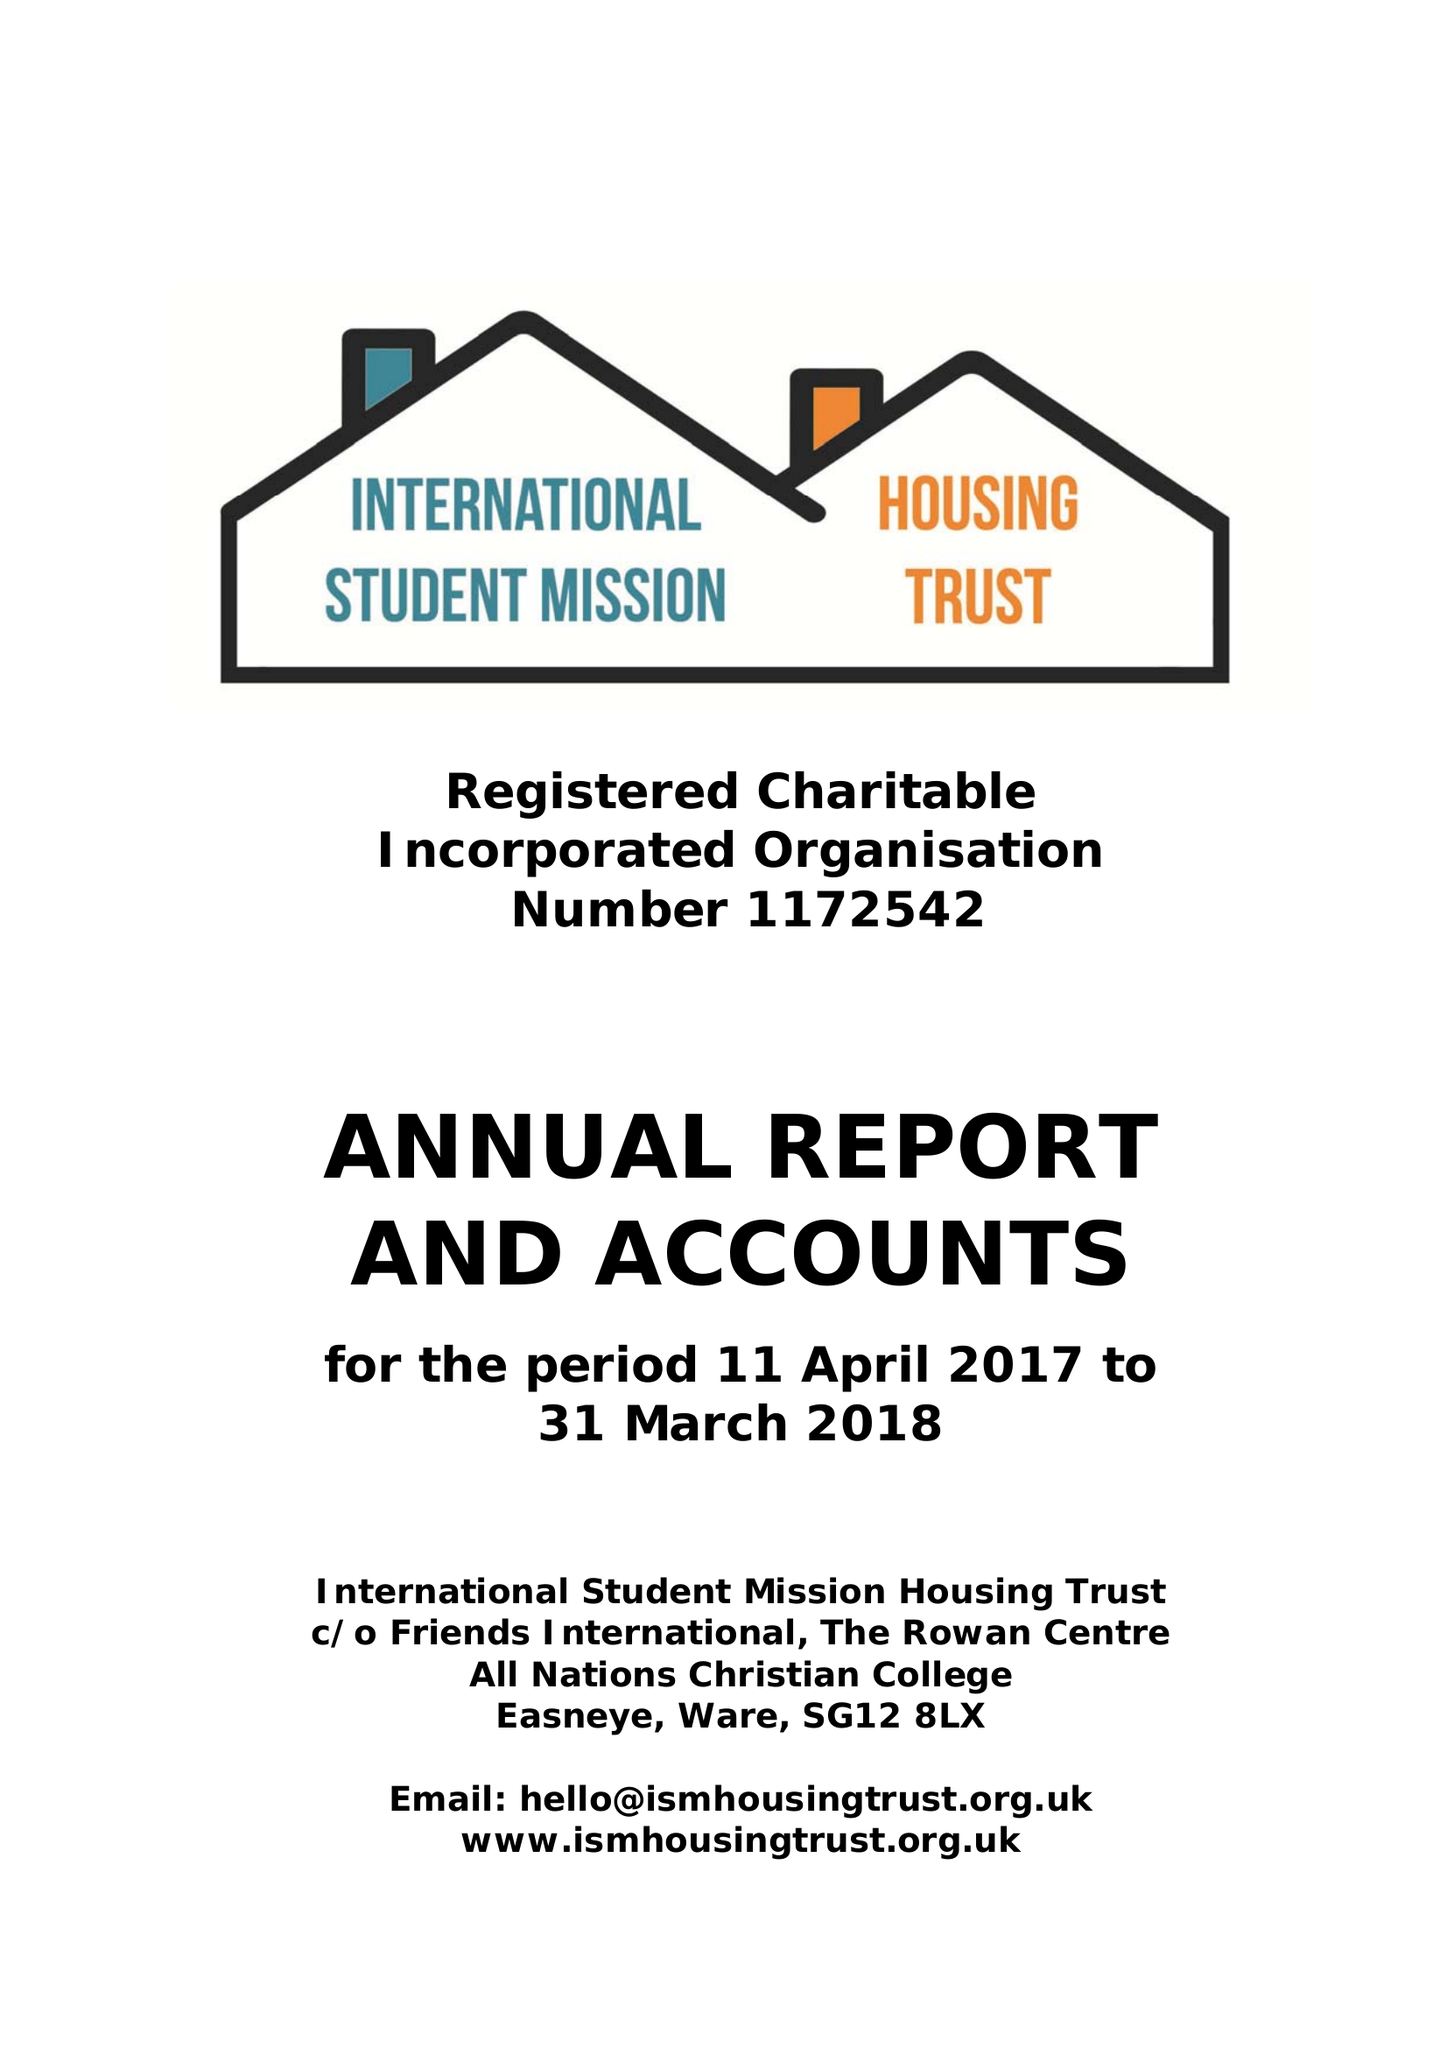What is the value for the income_annually_in_british_pounds?
Answer the question using a single word or phrase. 305567.00 